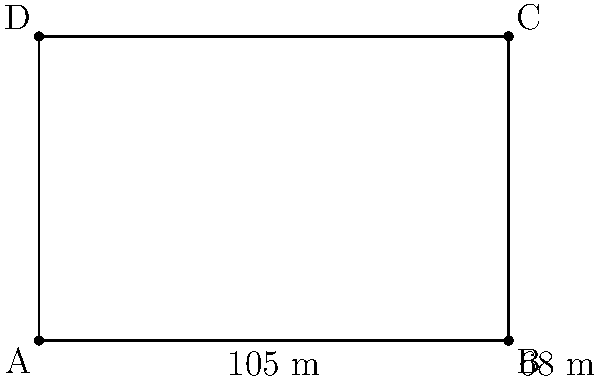As a former professional soccer player, you're tasked with calculating the area of a standard soccer field for an insurance policy. Given that the field measures 105 meters in length and 68 meters in width, what is the total area of the field in square meters? To calculate the area of a rectangular soccer field, we need to multiply its length by its width. Let's break it down step-by-step:

1. Identify the given dimensions:
   Length (l) = 105 meters
   Width (w) = 68 meters

2. Use the formula for the area of a rectangle:
   Area (A) = length × width
   A = l × w

3. Substitute the values into the formula:
   A = 105 m × 68 m

4. Perform the multiplication:
   A = 7,140 m²

Therefore, the total area of the soccer field is 7,140 square meters.
Answer: 7,140 m² 